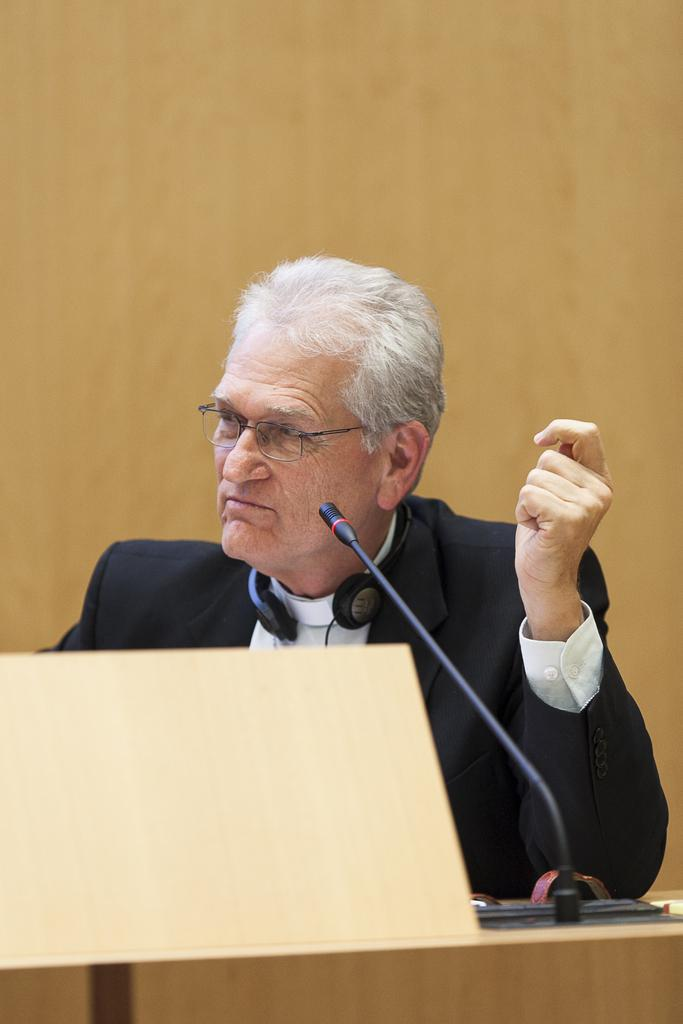Who is the main subject in the image? There is a person in the image. What is the person doing in the image? The person is standing in front of a table. What can be seen on the table? There is a mic on the table. What is the person wearing? The person is wearing spectacles and a coat. What is the color of the wall in the background? The wall in the background is cream colored. What type of garden can be seen in the image? There is no garden present in the image; it features a person standing in front of a table with a mic. How does the person divide their time between cooking and other activities in the image? The image does not show the person cooking or engaging in any other activities besides standing in front of a table with a mic. 